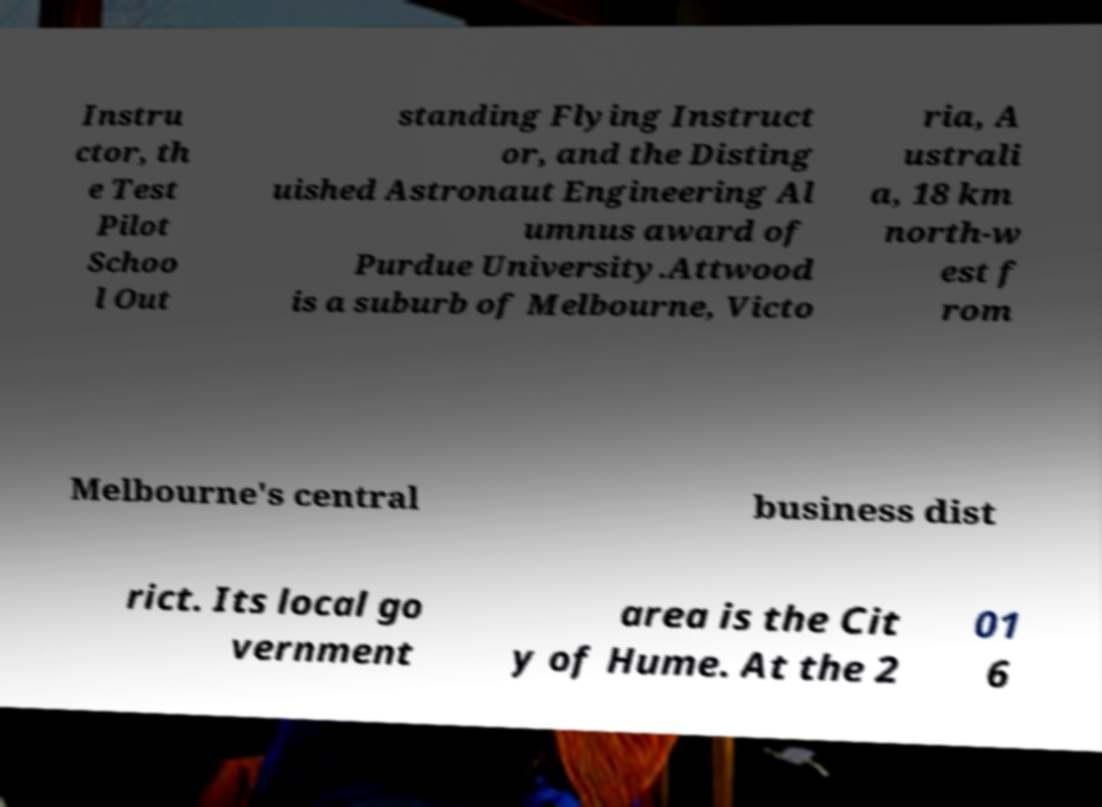There's text embedded in this image that I need extracted. Can you transcribe it verbatim? Instru ctor, th e Test Pilot Schoo l Out standing Flying Instruct or, and the Disting uished Astronaut Engineering Al umnus award of Purdue University.Attwood is a suburb of Melbourne, Victo ria, A ustrali a, 18 km north-w est f rom Melbourne's central business dist rict. Its local go vernment area is the Cit y of Hume. At the 2 01 6 